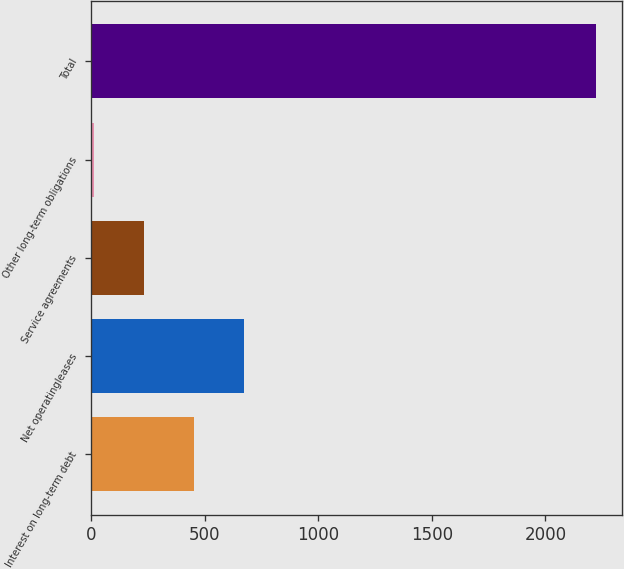<chart> <loc_0><loc_0><loc_500><loc_500><bar_chart><fcel>Interest on long-term debt<fcel>Net operatingleases<fcel>Service agreements<fcel>Other long-term obligations<fcel>Total<nl><fcel>454.4<fcel>675.6<fcel>233.2<fcel>12<fcel>2224<nl></chart> 